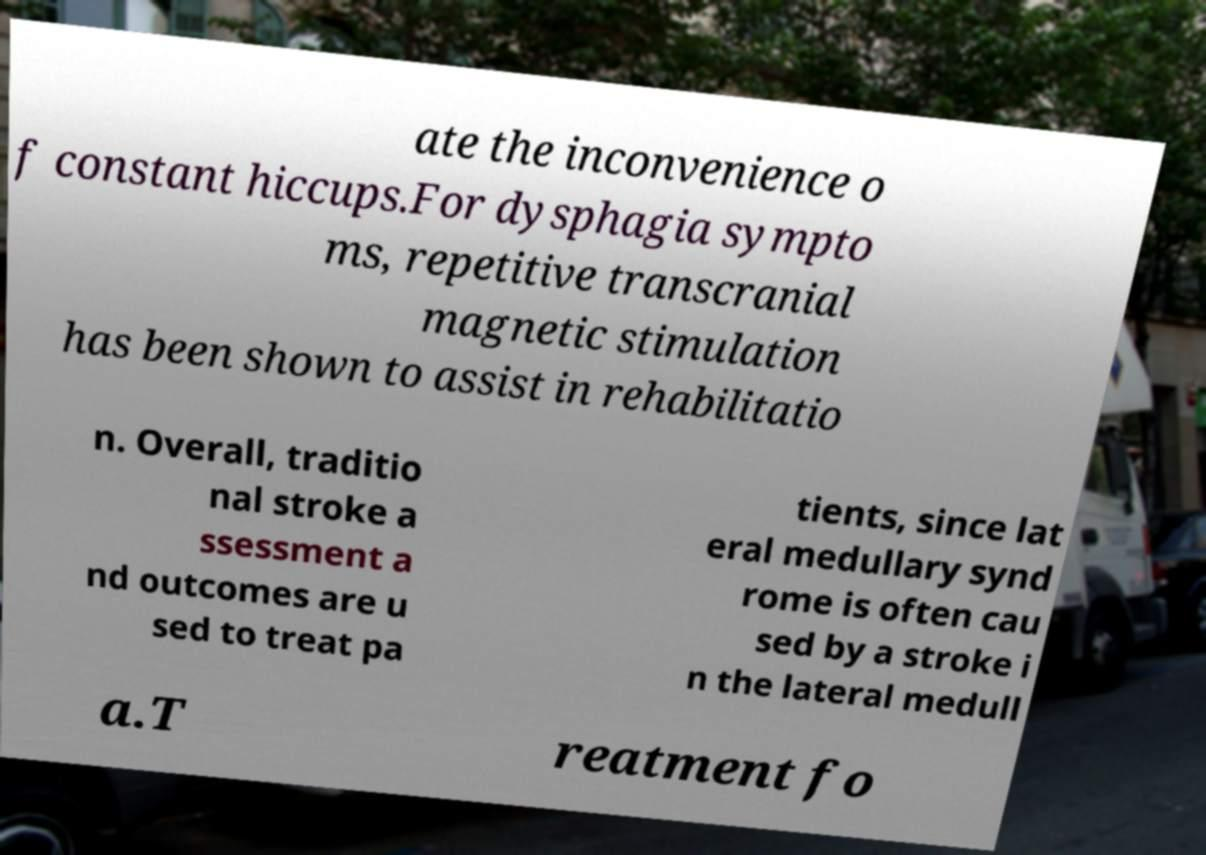What messages or text are displayed in this image? I need them in a readable, typed format. ate the inconvenience o f constant hiccups.For dysphagia sympto ms, repetitive transcranial magnetic stimulation has been shown to assist in rehabilitatio n. Overall, traditio nal stroke a ssessment a nd outcomes are u sed to treat pa tients, since lat eral medullary synd rome is often cau sed by a stroke i n the lateral medull a.T reatment fo 